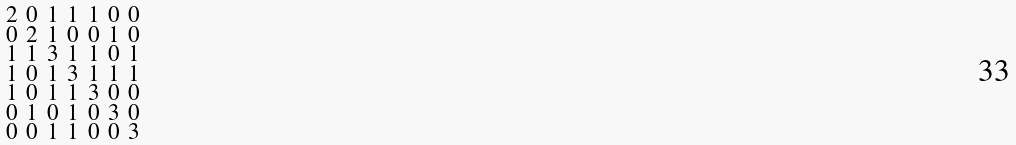Convert formula to latex. <formula><loc_0><loc_0><loc_500><loc_500>\begin{smallmatrix} 2 & 0 & 1 & 1 & 1 & 0 & 0 \\ 0 & 2 & 1 & 0 & 0 & 1 & 0 \\ 1 & 1 & 3 & 1 & 1 & 0 & 1 \\ 1 & 0 & 1 & 3 & 1 & 1 & 1 \\ 1 & 0 & 1 & 1 & 3 & 0 & 0 \\ 0 & 1 & 0 & 1 & 0 & 3 & 0 \\ 0 & 0 & 1 & 1 & 0 & 0 & 3 \end{smallmatrix}</formula> 